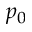<formula> <loc_0><loc_0><loc_500><loc_500>p _ { 0 }</formula> 